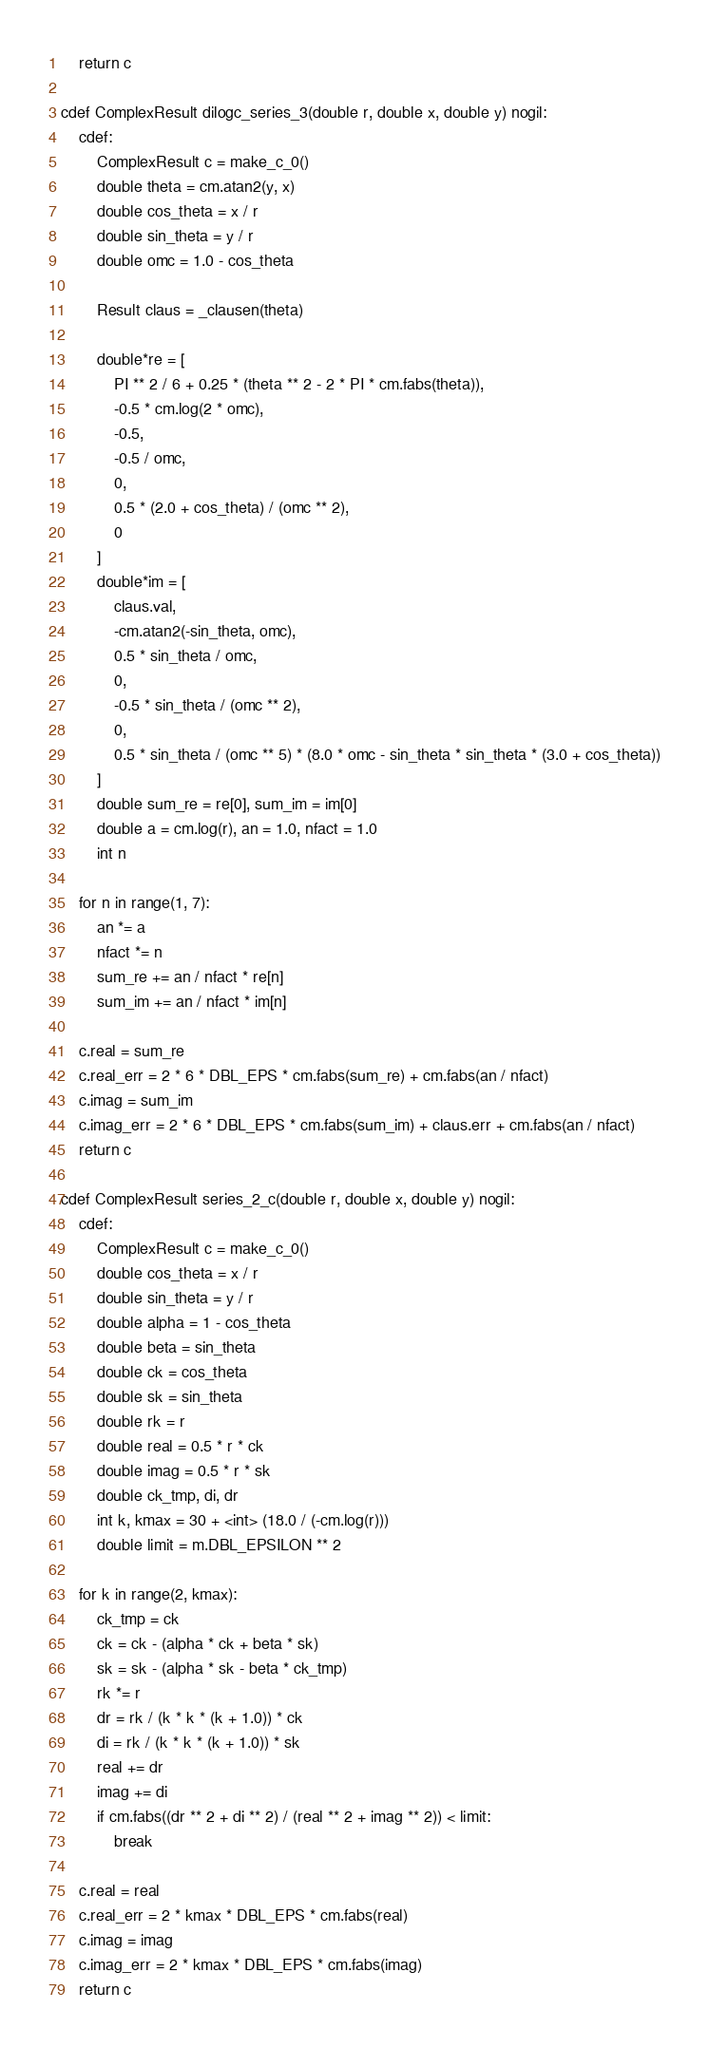<code> <loc_0><loc_0><loc_500><loc_500><_Cython_>    return c

cdef ComplexResult dilogc_series_3(double r, double x, double y) nogil:
    cdef:
        ComplexResult c = make_c_0()
        double theta = cm.atan2(y, x)
        double cos_theta = x / r
        double sin_theta = y / r
        double omc = 1.0 - cos_theta

        Result claus = _clausen(theta)

        double*re = [
            PI ** 2 / 6 + 0.25 * (theta ** 2 - 2 * PI * cm.fabs(theta)),
            -0.5 * cm.log(2 * omc),
            -0.5,
            -0.5 / omc,
            0,
            0.5 * (2.0 + cos_theta) / (omc ** 2),
            0
        ]
        double*im = [
            claus.val,
            -cm.atan2(-sin_theta, omc),
            0.5 * sin_theta / omc,
            0,
            -0.5 * sin_theta / (omc ** 2),
            0,
            0.5 * sin_theta / (omc ** 5) * (8.0 * omc - sin_theta * sin_theta * (3.0 + cos_theta))
        ]
        double sum_re = re[0], sum_im = im[0]
        double a = cm.log(r), an = 1.0, nfact = 1.0
        int n

    for n in range(1, 7):
        an *= a
        nfact *= n
        sum_re += an / nfact * re[n]
        sum_im += an / nfact * im[n]

    c.real = sum_re
    c.real_err = 2 * 6 * DBL_EPS * cm.fabs(sum_re) + cm.fabs(an / nfact)
    c.imag = sum_im
    c.imag_err = 2 * 6 * DBL_EPS * cm.fabs(sum_im) + claus.err + cm.fabs(an / nfact)
    return c

cdef ComplexResult series_2_c(double r, double x, double y) nogil:
    cdef:
        ComplexResult c = make_c_0()
        double cos_theta = x / r
        double sin_theta = y / r
        double alpha = 1 - cos_theta
        double beta = sin_theta
        double ck = cos_theta
        double sk = sin_theta
        double rk = r
        double real = 0.5 * r * ck
        double imag = 0.5 * r * sk
        double ck_tmp, di, dr
        int k, kmax = 30 + <int> (18.0 / (-cm.log(r)))
        double limit = m.DBL_EPSILON ** 2

    for k in range(2, kmax):
        ck_tmp = ck
        ck = ck - (alpha * ck + beta * sk)
        sk = sk - (alpha * sk - beta * ck_tmp)
        rk *= r
        dr = rk / (k * k * (k + 1.0)) * ck
        di = rk / (k * k * (k + 1.0)) * sk
        real += dr
        imag += di
        if cm.fabs((dr ** 2 + di ** 2) / (real ** 2 + imag ** 2)) < limit:
            break

    c.real = real
    c.real_err = 2 * kmax * DBL_EPS * cm.fabs(real)
    c.imag = imag
    c.imag_err = 2 * kmax * DBL_EPS * cm.fabs(imag)
    return c
</code> 